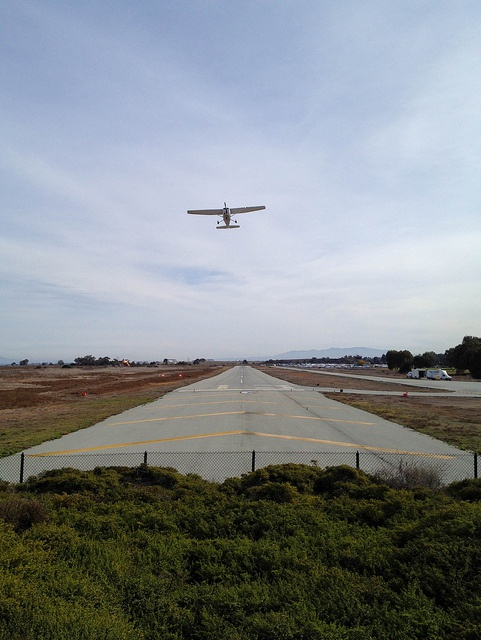Describe the objects in this image and their specific colors. I can see airplane in darkgray, gray, and black tones, truck in darkgray, gray, and black tones, and truck in darkgray, gray, and black tones in this image. 